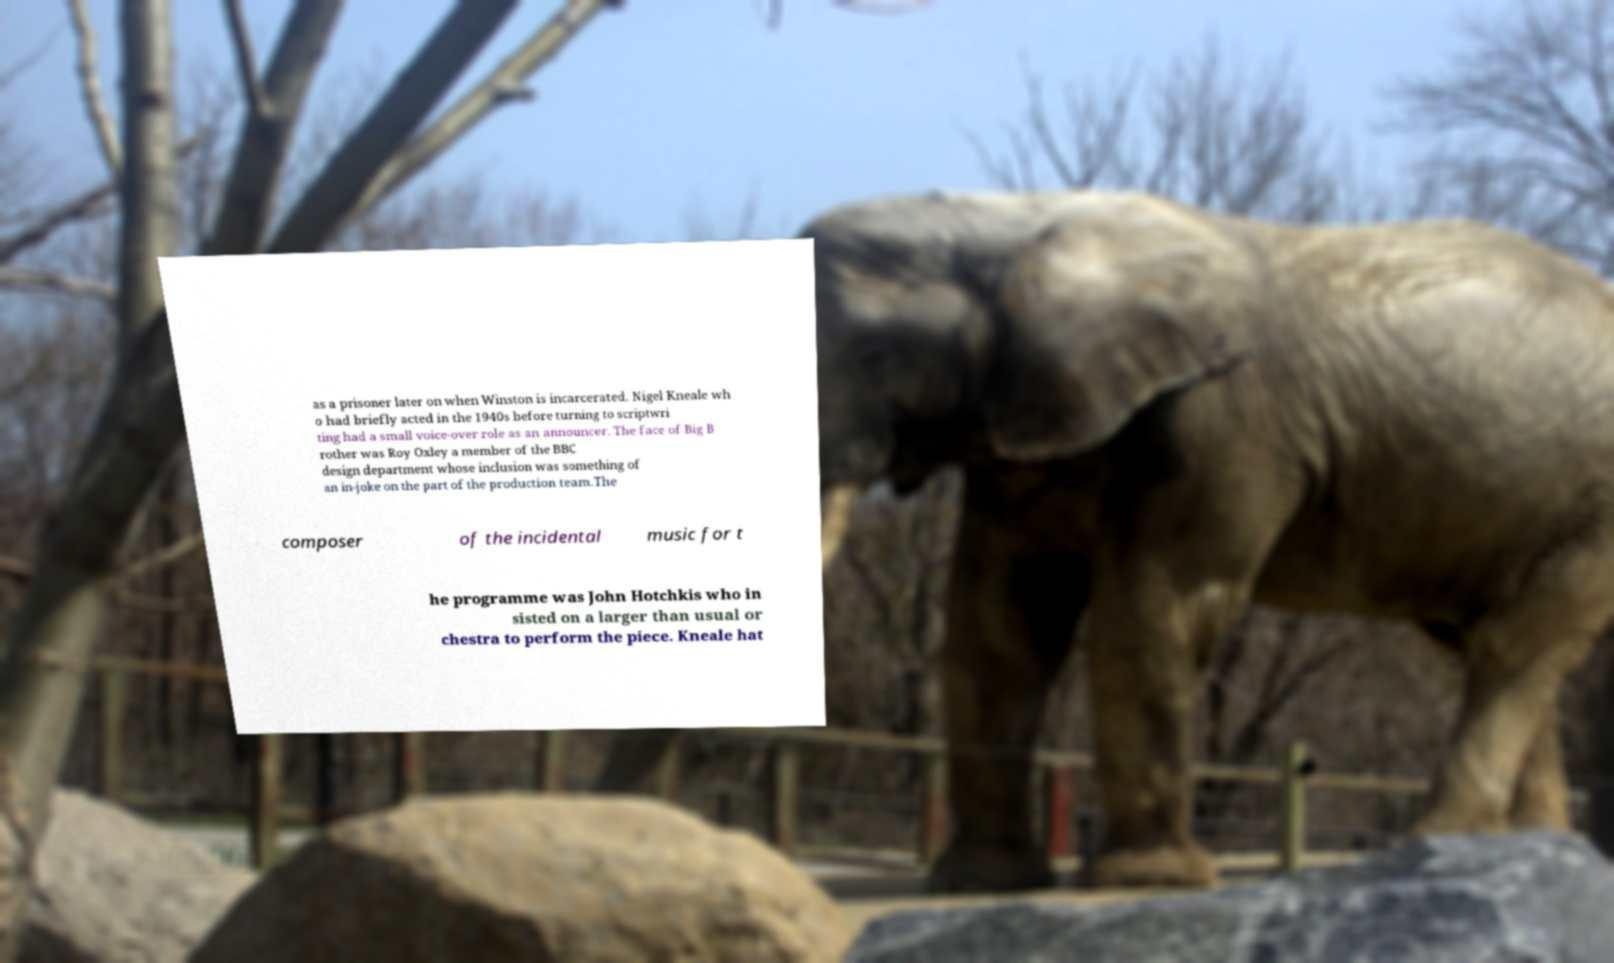Can you read and provide the text displayed in the image?This photo seems to have some interesting text. Can you extract and type it out for me? as a prisoner later on when Winston is incarcerated. Nigel Kneale wh o had briefly acted in the 1940s before turning to scriptwri ting had a small voice-over role as an announcer. The face of Big B rother was Roy Oxley a member of the BBC design department whose inclusion was something of an in-joke on the part of the production team.The composer of the incidental music for t he programme was John Hotchkis who in sisted on a larger than usual or chestra to perform the piece. Kneale hat 